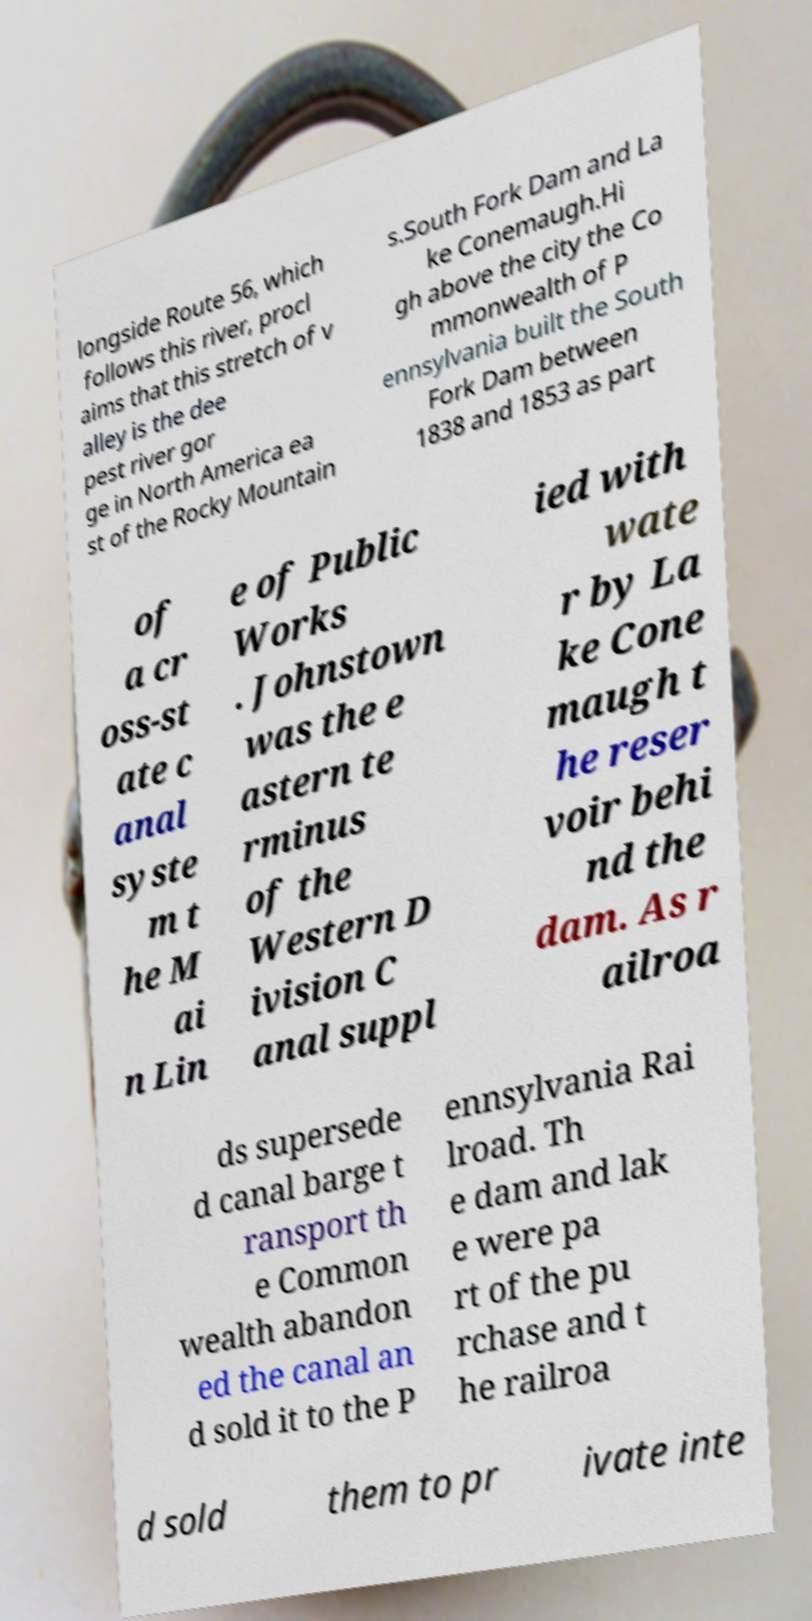I need the written content from this picture converted into text. Can you do that? longside Route 56, which follows this river, procl aims that this stretch of v alley is the dee pest river gor ge in North America ea st of the Rocky Mountain s.South Fork Dam and La ke Conemaugh.Hi gh above the city the Co mmonwealth of P ennsylvania built the South Fork Dam between 1838 and 1853 as part of a cr oss-st ate c anal syste m t he M ai n Lin e of Public Works . Johnstown was the e astern te rminus of the Western D ivision C anal suppl ied with wate r by La ke Cone maugh t he reser voir behi nd the dam. As r ailroa ds supersede d canal barge t ransport th e Common wealth abandon ed the canal an d sold it to the P ennsylvania Rai lroad. Th e dam and lak e were pa rt of the pu rchase and t he railroa d sold them to pr ivate inte 